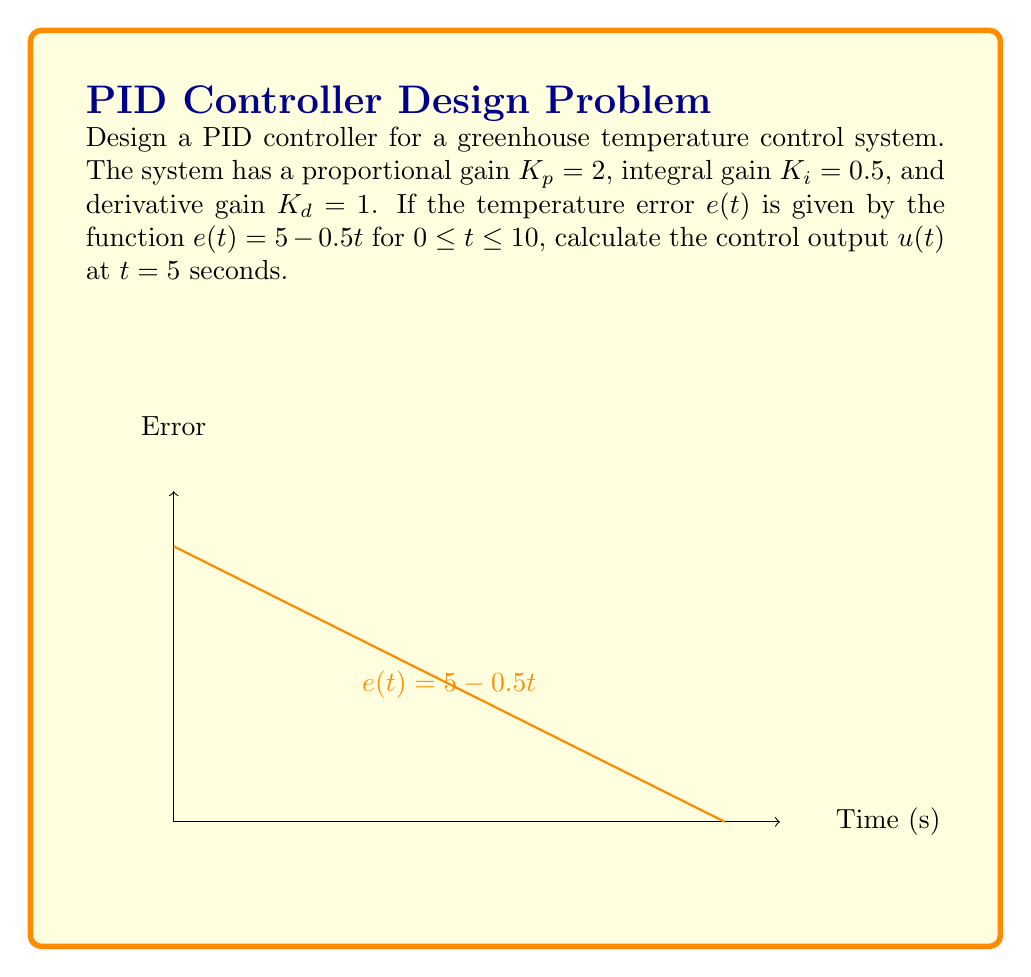Solve this math problem. Let's break this down step-by-step:

1) The PID controller equation is:

   $$u(t) = K_p e(t) + K_i \int_0^t e(\tau) d\tau + K_d \frac{de(t)}{dt}$$

2) We're given:
   $K_p = 2$, $K_i = 0.5$, $K_d = 1$, and $e(t) = 5 - 0.5t$

3) Let's calculate each term separately at $t = 5$:

   a) Proportional term: $K_p e(t) = 2 * (5 - 0.5*5) = 2 * 2.5 = 5$

   b) Integral term: 
      $$K_i \int_0^t e(\tau) d\tau = 0.5 \int_0^5 (5 - 0.5\tau) d\tau$$
      $$= 0.5 [5\tau - 0.25\tau^2]_0^5 = 0.5 * (25 - 6.25) = 9.375$$

   c) Derivative term: 
      $$K_d \frac{de(t)}{dt} = 1 * \frac{d}{dt}(5 - 0.5t) = -0.5$$

4) Sum all terms:
   $$u(5) = 5 + 9.375 - 0.5 = 13.875$$
Answer: $13.875$ 